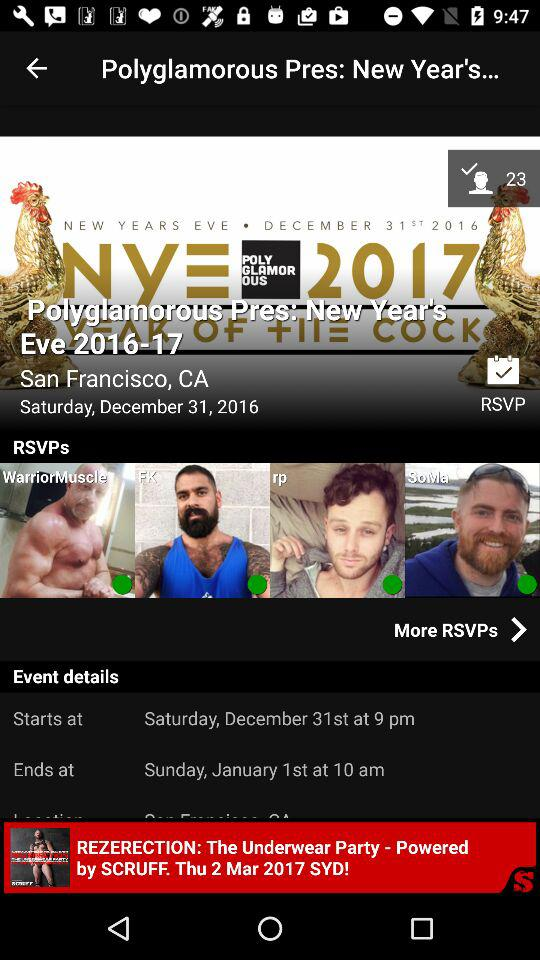In what year will the "Polyglamorous Pres: New Year's Eve" be held? The "Polyglamorous Pres: New Year's Eve" will be held from 2016 to 2017. 